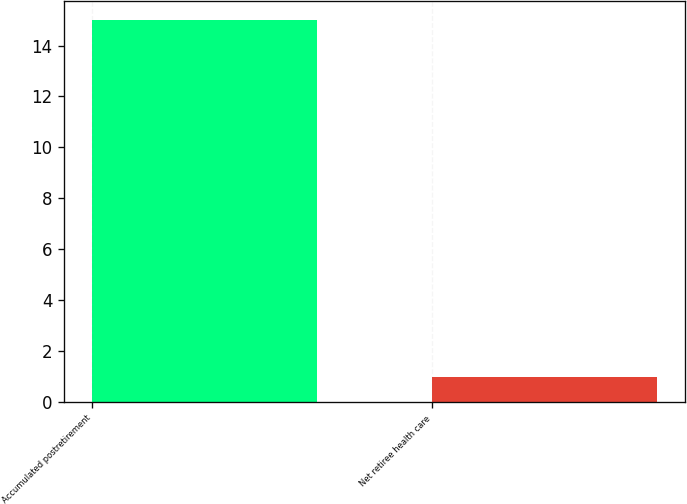<chart> <loc_0><loc_0><loc_500><loc_500><bar_chart><fcel>Accumulated postretirement<fcel>Net retiree health care<nl><fcel>15<fcel>1<nl></chart> 